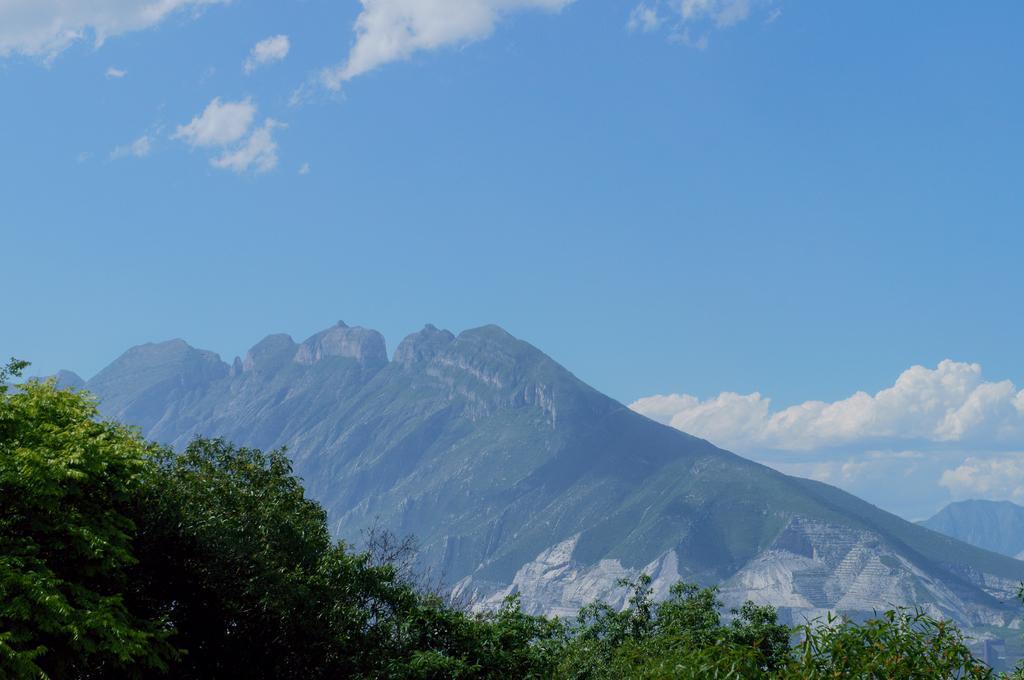In one or two sentences, can you explain what this image depicts? In this picture we can see mountains, trees and in the background we can see the sky with clouds. 